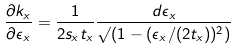<formula> <loc_0><loc_0><loc_500><loc_500>\frac { \partial k _ { x } } { \partial \epsilon _ { x } } = \frac { 1 } { 2 s _ { x } t _ { x } } \frac { d \epsilon _ { x } } { \surd ( 1 - ( \epsilon _ { x } / ( 2 t _ { x } ) ) ^ { 2 } ) }</formula> 